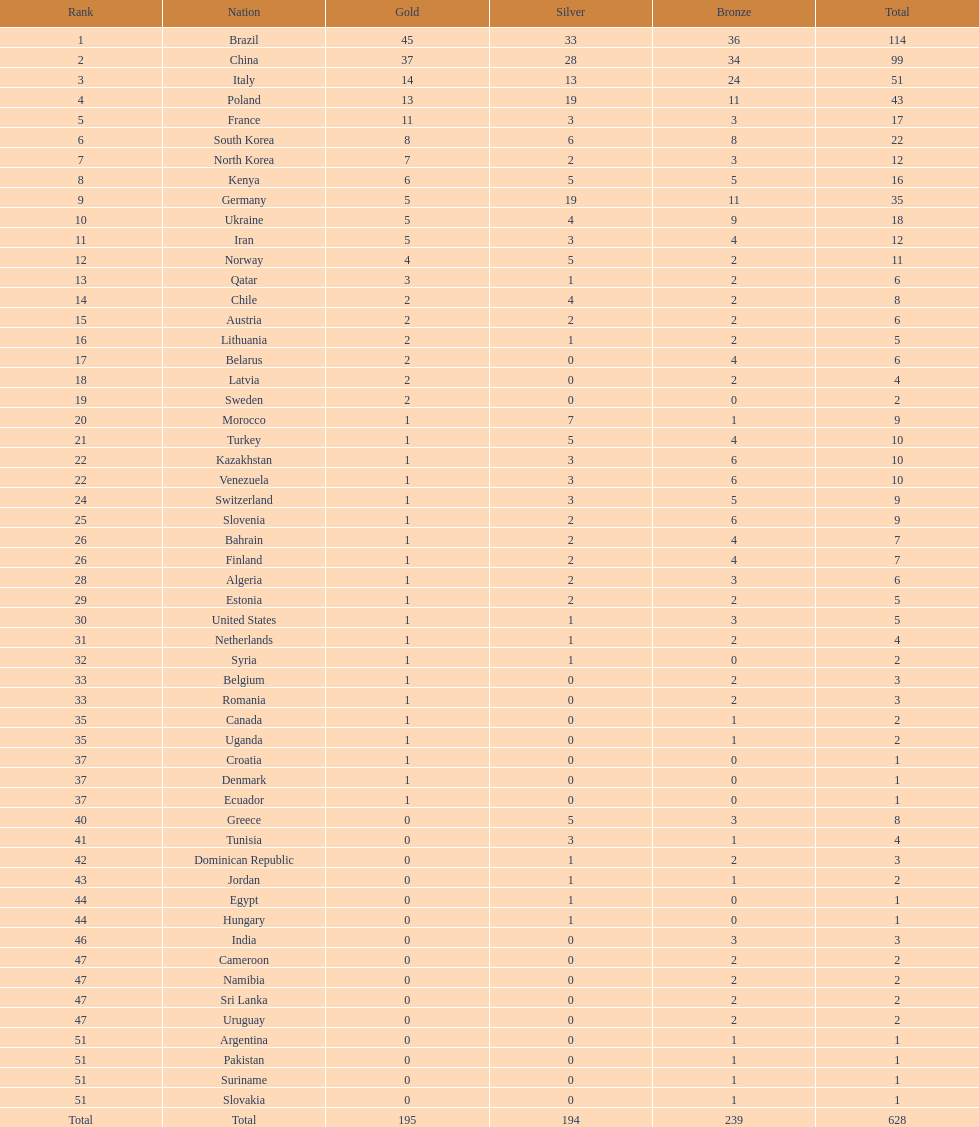What is the difference in the number of medals between south korea and north korea? 10. I'm looking to parse the entire table for insights. Could you assist me with that? {'header': ['Rank', 'Nation', 'Gold', 'Silver', 'Bronze', 'Total'], 'rows': [['1', 'Brazil', '45', '33', '36', '114'], ['2', 'China', '37', '28', '34', '99'], ['3', 'Italy', '14', '13', '24', '51'], ['4', 'Poland', '13', '19', '11', '43'], ['5', 'France', '11', '3', '3', '17'], ['6', 'South Korea', '8', '6', '8', '22'], ['7', 'North Korea', '7', '2', '3', '12'], ['8', 'Kenya', '6', '5', '5', '16'], ['9', 'Germany', '5', '19', '11', '35'], ['10', 'Ukraine', '5', '4', '9', '18'], ['11', 'Iran', '5', '3', '4', '12'], ['12', 'Norway', '4', '5', '2', '11'], ['13', 'Qatar', '3', '1', '2', '6'], ['14', 'Chile', '2', '4', '2', '8'], ['15', 'Austria', '2', '2', '2', '6'], ['16', 'Lithuania', '2', '1', '2', '5'], ['17', 'Belarus', '2', '0', '4', '6'], ['18', 'Latvia', '2', '0', '2', '4'], ['19', 'Sweden', '2', '0', '0', '2'], ['20', 'Morocco', '1', '7', '1', '9'], ['21', 'Turkey', '1', '5', '4', '10'], ['22', 'Kazakhstan', '1', '3', '6', '10'], ['22', 'Venezuela', '1', '3', '6', '10'], ['24', 'Switzerland', '1', '3', '5', '9'], ['25', 'Slovenia', '1', '2', '6', '9'], ['26', 'Bahrain', '1', '2', '4', '7'], ['26', 'Finland', '1', '2', '4', '7'], ['28', 'Algeria', '1', '2', '3', '6'], ['29', 'Estonia', '1', '2', '2', '5'], ['30', 'United States', '1', '1', '3', '5'], ['31', 'Netherlands', '1', '1', '2', '4'], ['32', 'Syria', '1', '1', '0', '2'], ['33', 'Belgium', '1', '0', '2', '3'], ['33', 'Romania', '1', '0', '2', '3'], ['35', 'Canada', '1', '0', '1', '2'], ['35', 'Uganda', '1', '0', '1', '2'], ['37', 'Croatia', '1', '0', '0', '1'], ['37', 'Denmark', '1', '0', '0', '1'], ['37', 'Ecuador', '1', '0', '0', '1'], ['40', 'Greece', '0', '5', '3', '8'], ['41', 'Tunisia', '0', '3', '1', '4'], ['42', 'Dominican Republic', '0', '1', '2', '3'], ['43', 'Jordan', '0', '1', '1', '2'], ['44', 'Egypt', '0', '1', '0', '1'], ['44', 'Hungary', '0', '1', '0', '1'], ['46', 'India', '0', '0', '3', '3'], ['47', 'Cameroon', '0', '0', '2', '2'], ['47', 'Namibia', '0', '0', '2', '2'], ['47', 'Sri Lanka', '0', '0', '2', '2'], ['47', 'Uruguay', '0', '0', '2', '2'], ['51', 'Argentina', '0', '0', '1', '1'], ['51', 'Pakistan', '0', '0', '1', '1'], ['51', 'Suriname', '0', '0', '1', '1'], ['51', 'Slovakia', '0', '0', '1', '1'], ['Total', 'Total', '195', '194', '239', '628']]} 